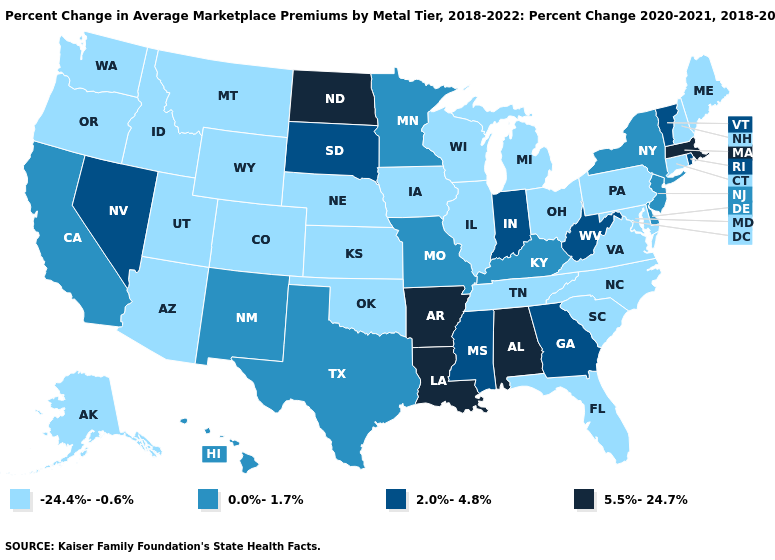What is the value of Kansas?
Short answer required. -24.4%--0.6%. Name the states that have a value in the range -24.4%--0.6%?
Concise answer only. Alaska, Arizona, Colorado, Connecticut, Florida, Idaho, Illinois, Iowa, Kansas, Maine, Maryland, Michigan, Montana, Nebraska, New Hampshire, North Carolina, Ohio, Oklahoma, Oregon, Pennsylvania, South Carolina, Tennessee, Utah, Virginia, Washington, Wisconsin, Wyoming. What is the value of Nebraska?
Answer briefly. -24.4%--0.6%. Does the first symbol in the legend represent the smallest category?
Write a very short answer. Yes. Name the states that have a value in the range 2.0%-4.8%?
Keep it brief. Georgia, Indiana, Mississippi, Nevada, Rhode Island, South Dakota, Vermont, West Virginia. Among the states that border New York , which have the highest value?
Short answer required. Massachusetts. Does North Dakota have the highest value in the MidWest?
Answer briefly. Yes. Among the states that border New York , does Massachusetts have the lowest value?
Concise answer only. No. Does the first symbol in the legend represent the smallest category?
Concise answer only. Yes. Does Vermont have the highest value in the USA?
Answer briefly. No. Name the states that have a value in the range 5.5%-24.7%?
Keep it brief. Alabama, Arkansas, Louisiana, Massachusetts, North Dakota. What is the highest value in states that border Pennsylvania?
Write a very short answer. 2.0%-4.8%. Name the states that have a value in the range 0.0%-1.7%?
Be succinct. California, Delaware, Hawaii, Kentucky, Minnesota, Missouri, New Jersey, New Mexico, New York, Texas. Name the states that have a value in the range 2.0%-4.8%?
Short answer required. Georgia, Indiana, Mississippi, Nevada, Rhode Island, South Dakota, Vermont, West Virginia. Name the states that have a value in the range 0.0%-1.7%?
Give a very brief answer. California, Delaware, Hawaii, Kentucky, Minnesota, Missouri, New Jersey, New Mexico, New York, Texas. 